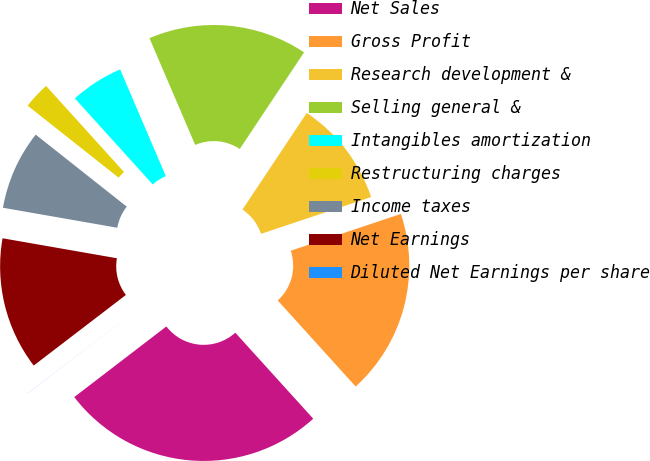Convert chart. <chart><loc_0><loc_0><loc_500><loc_500><pie_chart><fcel>Net Sales<fcel>Gross Profit<fcel>Research development &<fcel>Selling general &<fcel>Intangibles amortization<fcel>Restructuring charges<fcel>Income taxes<fcel>Net Earnings<fcel>Diluted Net Earnings per share<nl><fcel>26.31%<fcel>18.42%<fcel>10.53%<fcel>15.79%<fcel>5.27%<fcel>2.64%<fcel>7.9%<fcel>13.16%<fcel>0.01%<nl></chart> 